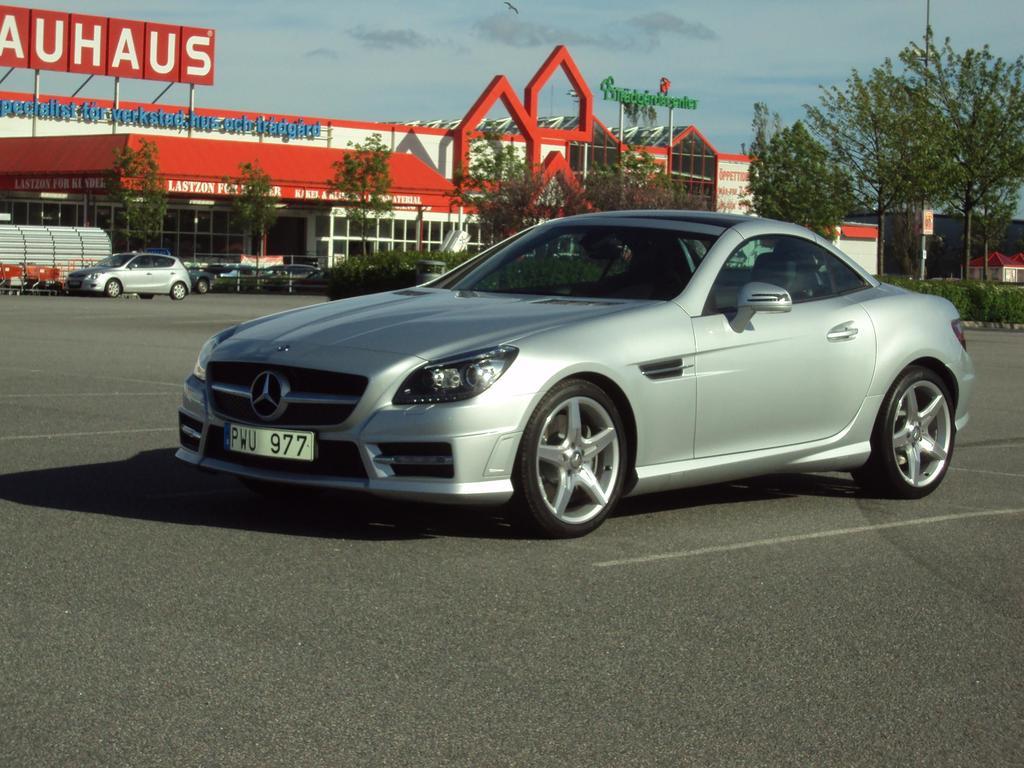What's the license plate number of this car?
Provide a short and direct response. Pwu 977. What letters are on the red sign in white?
Give a very brief answer. Auhaus. 